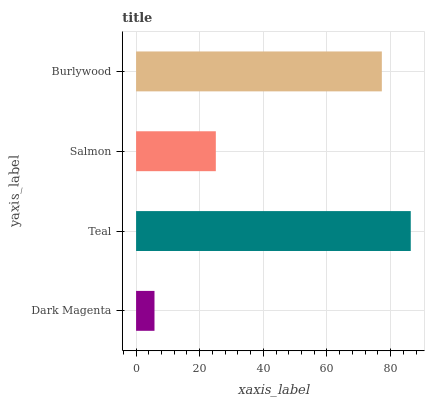Is Dark Magenta the minimum?
Answer yes or no. Yes. Is Teal the maximum?
Answer yes or no. Yes. Is Salmon the minimum?
Answer yes or no. No. Is Salmon the maximum?
Answer yes or no. No. Is Teal greater than Salmon?
Answer yes or no. Yes. Is Salmon less than Teal?
Answer yes or no. Yes. Is Salmon greater than Teal?
Answer yes or no. No. Is Teal less than Salmon?
Answer yes or no. No. Is Burlywood the high median?
Answer yes or no. Yes. Is Salmon the low median?
Answer yes or no. Yes. Is Teal the high median?
Answer yes or no. No. Is Teal the low median?
Answer yes or no. No. 